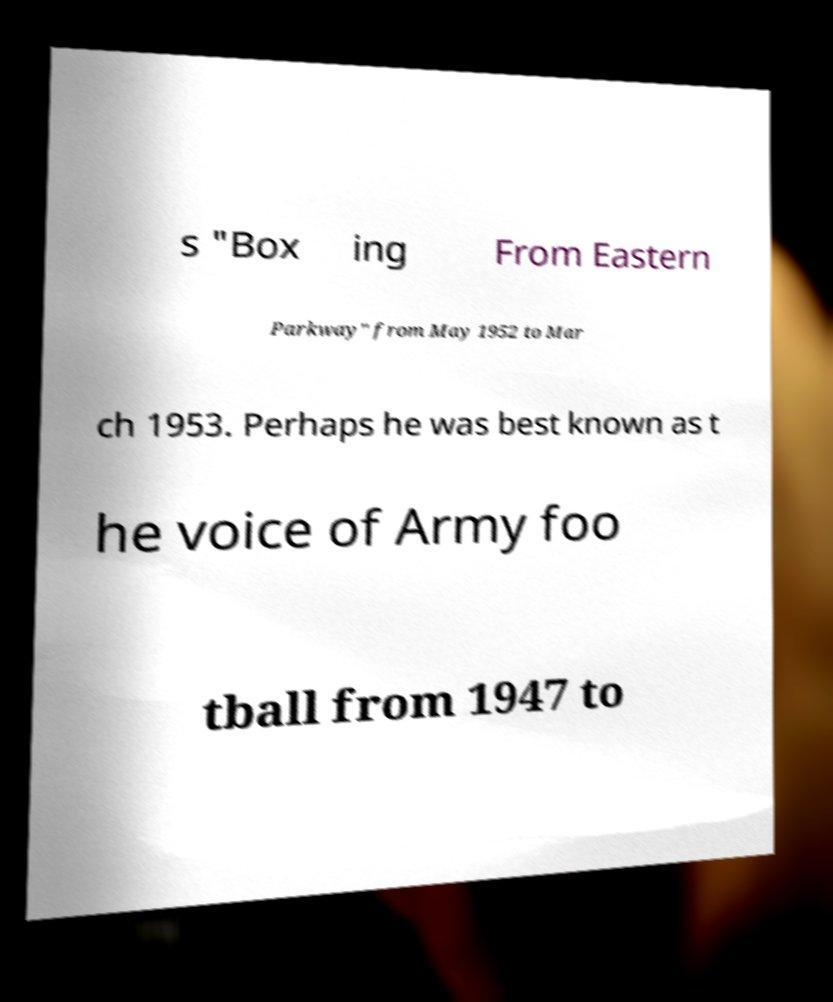Please identify and transcribe the text found in this image. s "Box ing From Eastern Parkway" from May 1952 to Mar ch 1953. Perhaps he was best known as t he voice of Army foo tball from 1947 to 